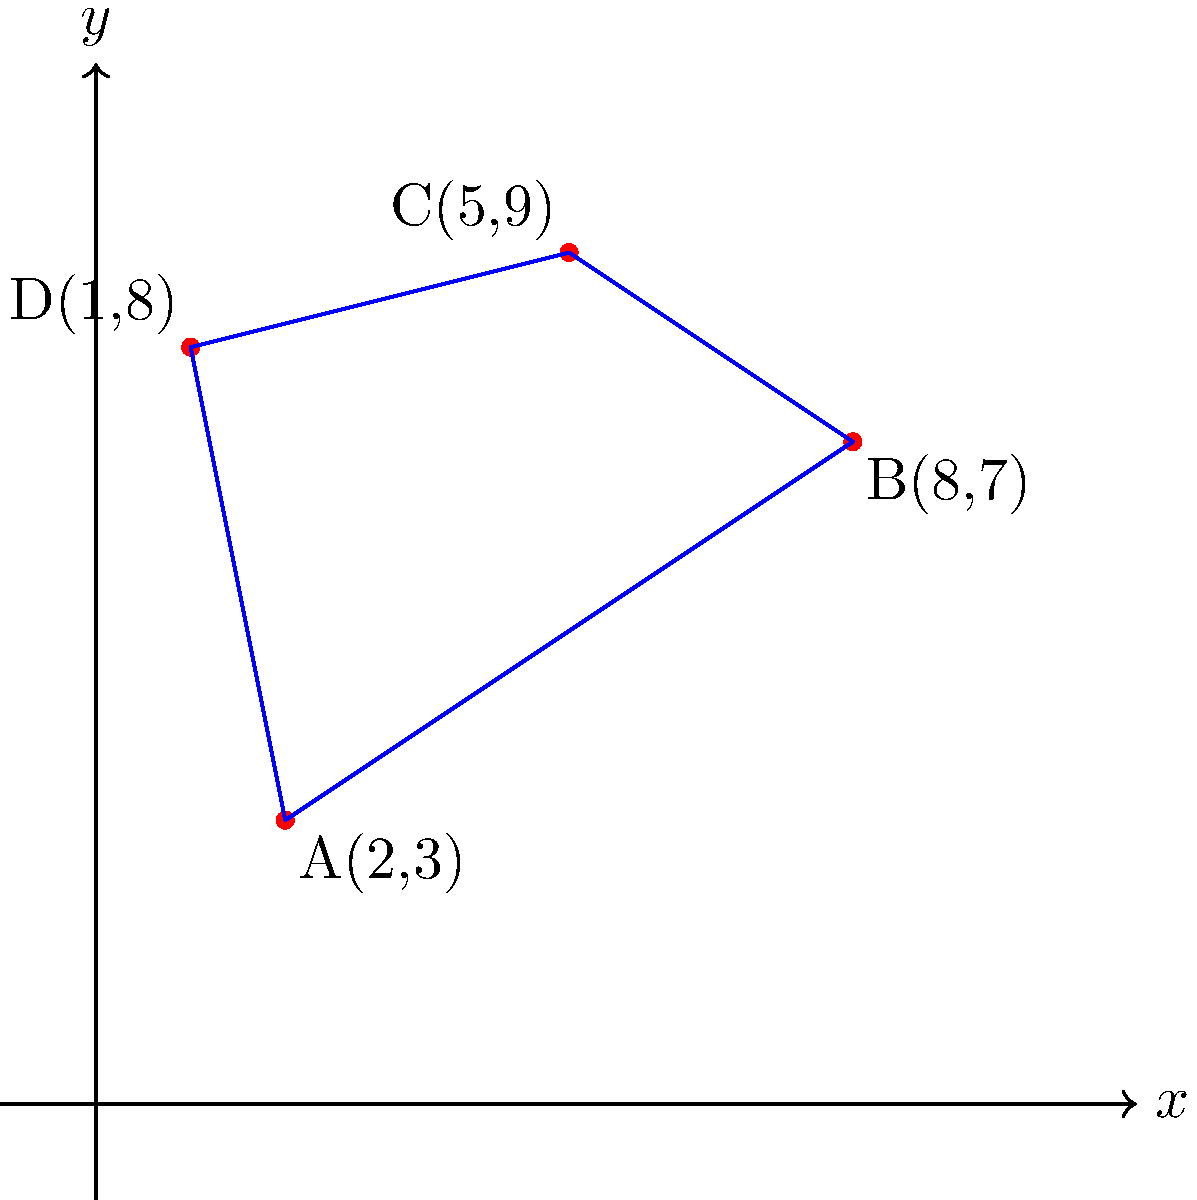As the lead performer, you're planning a new dance routine for the cruise ship's main stage. The choreographer has given you the positions of four dancers in Cartesian coordinates: A(2,3), B(8,7), C(5,9), and D(1,8). These dancers will form the corners of the performance area. Calculate the area of the stage that will be covered by this performance, assuming the coordinates are in meters. To find the area of the irregular quadrilateral formed by the four dancers, we can use the shoelace formula (also known as the surveyor's formula). Here's how to solve it step-by-step:

1) The shoelace formula for a quadrilateral with vertices $(x_1, y_1)$, $(x_2, y_2)$, $(x_3, y_3)$, and $(x_4, y_4)$ is:

   Area = $\frac{1}{2}|x_1y_2 + x_2y_3 + x_3y_4 + x_4y_1 - y_1x_2 - y_2x_3 - y_3x_4 - y_4x_1|$

2) Substitute the given coordinates:
   A(2,3), B(8,7), C(5,9), D(1,8)

3) Apply the formula:
   Area = $\frac{1}{2}|(2\cdot7 + 8\cdot9 + 5\cdot8 + 1\cdot3) - (3\cdot8 + 7\cdot5 + 9\cdot1 + 8\cdot2)|$

4) Calculate the products:
   Area = $\frac{1}{2}|(14 + 72 + 40 + 3) - (24 + 35 + 9 + 16)|$

5) Sum the terms:
   Area = $\frac{1}{2}|129 - 84|$

6) Subtract:
   Area = $\frac{1}{2}|45|$

7) Calculate the final result:
   Area = $\frac{45}{2} = 22.5$

Therefore, the area of the stage covered by the performance is 22.5 square meters.
Answer: 22.5 m² 